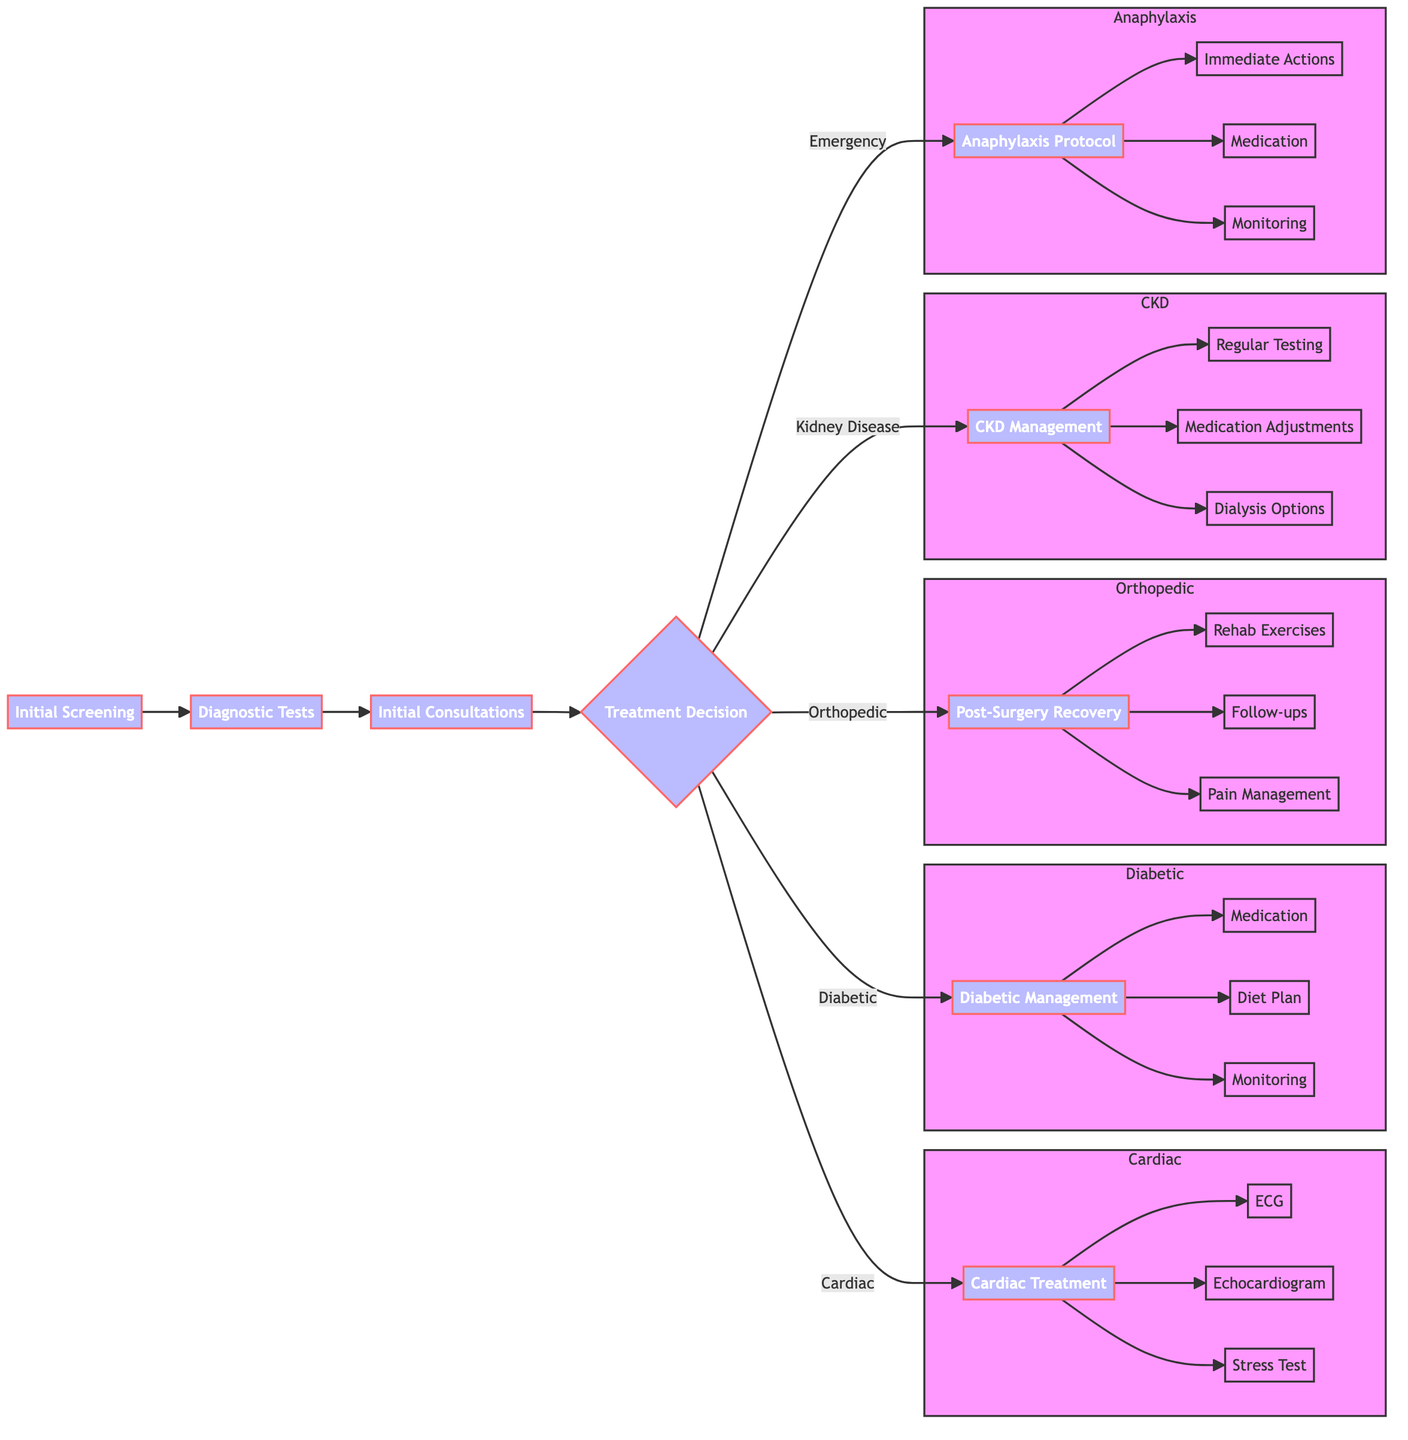What is the first step in the assessment and diagnosis workflow for cardiac patients? The first step is "Initial Screening," which is where medical history review, physical examination, blood pressure measurement, and ECG are conducted.
Answer: Initial Screening How many main treatment pathways are depicted in the diagram? The diagram shows five main treatment pathways for cardiac, diabetic, orthopedic, chronic kidney disease, and emergency response protocols.
Answer: 5 What is one type of test included in the diagnostic tests for cardiac patients? The list of diagnostic tests includes an echocardiogram, stress test, blood tests, and coronary angiography. One of these types is an echocardiogram.
Answer: Echocardiogram Which pathway requires quarterly HbA1c testing? The pathway related to diabetic management includes regular monitoring schedules that feature quarterly HbA1c testing as one of its components.
Answer: Diabetic Management What immediate action should be taken in response to anaphylactic shock? The immediate actions listed in the emergency response protocol include calling emergency services and administering epinephrine. The first action is to call emergency services.
Answer: Call Emergency Services What are the components of the rehabilitation exercises in the post-surgery recovery process? The rehabilitation exercises include physical therapy sessions, range-of-motion exercises, and strengthening exercises as outlined in the diagram.
Answer: Physical Therapy Sessions, Range-of-Motion Exercises, Strengthening Exercises What is a medication adjustment option for chronic kidney disease management? The management pathway includes options for medication adjustments, which feature drugs such as ACE inhibitors, ARB drugs, and phosphate binders. One option is ACE inhibitors.
Answer: ACE Inhibitors What medication administration is indicated for anaphylaxis in the protocol? According to the emergency response protocol, the medication administration section includes antihistamines, corticosteroids, and inhaled beta-agonists. One of the specific administrations for anaphylaxis is administering epinephrine.
Answer: Epinephrine How often should patients have follow-up visits after orthopedic surgery? The follow-up visits scheduled as part of the post-surgery recovery process include a 1-week post-op check, a 1-month follow-up, and a 3-month evaluation, requiring three visits.
Answer: 3 Months Evaluation 